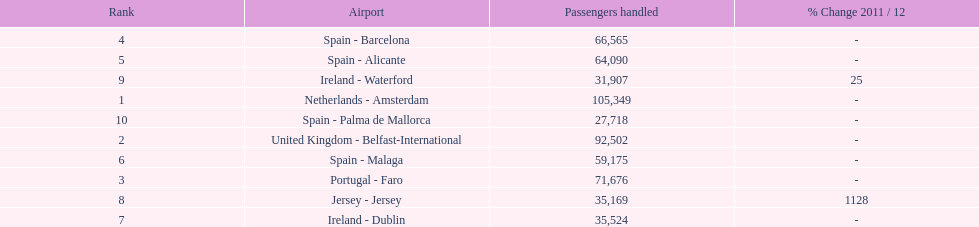Where is the most popular destination for passengers leaving london southend airport? Netherlands - Amsterdam. Parse the table in full. {'header': ['Rank', 'Airport', 'Passengers handled', '% Change 2011 / 12'], 'rows': [['4', 'Spain - Barcelona', '66,565', '-'], ['5', 'Spain - Alicante', '64,090', '-'], ['9', 'Ireland - Waterford', '31,907', '25'], ['1', 'Netherlands - Amsterdam', '105,349', '-'], ['10', 'Spain - Palma de Mallorca', '27,718', '-'], ['2', 'United Kingdom - Belfast-International', '92,502', '-'], ['6', 'Spain - Malaga', '59,175', '-'], ['3', 'Portugal - Faro', '71,676', '-'], ['8', 'Jersey - Jersey', '35,169', '1128'], ['7', 'Ireland - Dublin', '35,524', '-']]} 